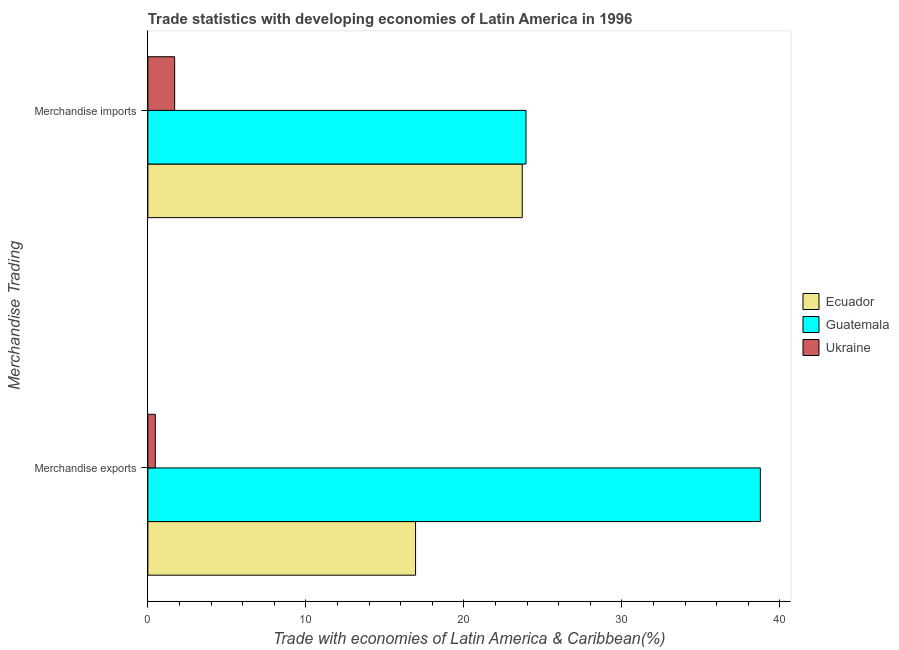How many different coloured bars are there?
Your response must be concise. 3. Are the number of bars per tick equal to the number of legend labels?
Ensure brevity in your answer.  Yes. Are the number of bars on each tick of the Y-axis equal?
Provide a succinct answer. Yes. How many bars are there on the 2nd tick from the bottom?
Your response must be concise. 3. What is the merchandise exports in Ukraine?
Provide a succinct answer. 0.47. Across all countries, what is the maximum merchandise exports?
Offer a very short reply. 38.77. Across all countries, what is the minimum merchandise imports?
Provide a succinct answer. 1.7. In which country was the merchandise imports maximum?
Your response must be concise. Guatemala. In which country was the merchandise imports minimum?
Make the answer very short. Ukraine. What is the total merchandise exports in the graph?
Offer a very short reply. 56.18. What is the difference between the merchandise imports in Guatemala and that in Ukraine?
Offer a terse response. 22.24. What is the difference between the merchandise imports in Ukraine and the merchandise exports in Ecuador?
Your answer should be very brief. -15.25. What is the average merchandise exports per country?
Your response must be concise. 18.73. What is the difference between the merchandise imports and merchandise exports in Ukraine?
Your answer should be compact. 1.23. What is the ratio of the merchandise exports in Ecuador to that in Ukraine?
Provide a succinct answer. 36.04. What does the 2nd bar from the top in Merchandise exports represents?
Keep it short and to the point. Guatemala. What does the 1st bar from the bottom in Merchandise exports represents?
Your answer should be compact. Ecuador. Are the values on the major ticks of X-axis written in scientific E-notation?
Make the answer very short. No. Does the graph contain any zero values?
Your response must be concise. No. What is the title of the graph?
Give a very brief answer. Trade statistics with developing economies of Latin America in 1996. What is the label or title of the X-axis?
Your answer should be very brief. Trade with economies of Latin America & Caribbean(%). What is the label or title of the Y-axis?
Offer a very short reply. Merchandise Trading. What is the Trade with economies of Latin America & Caribbean(%) in Ecuador in Merchandise exports?
Offer a very short reply. 16.94. What is the Trade with economies of Latin America & Caribbean(%) of Guatemala in Merchandise exports?
Your response must be concise. 38.77. What is the Trade with economies of Latin America & Caribbean(%) in Ukraine in Merchandise exports?
Provide a short and direct response. 0.47. What is the Trade with economies of Latin America & Caribbean(%) in Ecuador in Merchandise imports?
Offer a very short reply. 23.7. What is the Trade with economies of Latin America & Caribbean(%) in Guatemala in Merchandise imports?
Provide a succinct answer. 23.94. What is the Trade with economies of Latin America & Caribbean(%) of Ukraine in Merchandise imports?
Make the answer very short. 1.7. Across all Merchandise Trading, what is the maximum Trade with economies of Latin America & Caribbean(%) of Ecuador?
Ensure brevity in your answer.  23.7. Across all Merchandise Trading, what is the maximum Trade with economies of Latin America & Caribbean(%) in Guatemala?
Ensure brevity in your answer.  38.77. Across all Merchandise Trading, what is the maximum Trade with economies of Latin America & Caribbean(%) in Ukraine?
Make the answer very short. 1.7. Across all Merchandise Trading, what is the minimum Trade with economies of Latin America & Caribbean(%) of Ecuador?
Offer a very short reply. 16.94. Across all Merchandise Trading, what is the minimum Trade with economies of Latin America & Caribbean(%) in Guatemala?
Your response must be concise. 23.94. Across all Merchandise Trading, what is the minimum Trade with economies of Latin America & Caribbean(%) of Ukraine?
Provide a short and direct response. 0.47. What is the total Trade with economies of Latin America & Caribbean(%) of Ecuador in the graph?
Make the answer very short. 40.64. What is the total Trade with economies of Latin America & Caribbean(%) in Guatemala in the graph?
Your answer should be compact. 62.7. What is the total Trade with economies of Latin America & Caribbean(%) in Ukraine in the graph?
Keep it short and to the point. 2.17. What is the difference between the Trade with economies of Latin America & Caribbean(%) in Ecuador in Merchandise exports and that in Merchandise imports?
Provide a succinct answer. -6.75. What is the difference between the Trade with economies of Latin America & Caribbean(%) in Guatemala in Merchandise exports and that in Merchandise imports?
Offer a terse response. 14.83. What is the difference between the Trade with economies of Latin America & Caribbean(%) in Ukraine in Merchandise exports and that in Merchandise imports?
Give a very brief answer. -1.23. What is the difference between the Trade with economies of Latin America & Caribbean(%) in Ecuador in Merchandise exports and the Trade with economies of Latin America & Caribbean(%) in Guatemala in Merchandise imports?
Provide a short and direct response. -6.99. What is the difference between the Trade with economies of Latin America & Caribbean(%) of Ecuador in Merchandise exports and the Trade with economies of Latin America & Caribbean(%) of Ukraine in Merchandise imports?
Keep it short and to the point. 15.25. What is the difference between the Trade with economies of Latin America & Caribbean(%) in Guatemala in Merchandise exports and the Trade with economies of Latin America & Caribbean(%) in Ukraine in Merchandise imports?
Provide a short and direct response. 37.07. What is the average Trade with economies of Latin America & Caribbean(%) in Ecuador per Merchandise Trading?
Your response must be concise. 20.32. What is the average Trade with economies of Latin America & Caribbean(%) of Guatemala per Merchandise Trading?
Your response must be concise. 31.35. What is the average Trade with economies of Latin America & Caribbean(%) in Ukraine per Merchandise Trading?
Provide a succinct answer. 1.08. What is the difference between the Trade with economies of Latin America & Caribbean(%) of Ecuador and Trade with economies of Latin America & Caribbean(%) of Guatemala in Merchandise exports?
Make the answer very short. -21.82. What is the difference between the Trade with economies of Latin America & Caribbean(%) in Ecuador and Trade with economies of Latin America & Caribbean(%) in Ukraine in Merchandise exports?
Your answer should be very brief. 16.47. What is the difference between the Trade with economies of Latin America & Caribbean(%) in Guatemala and Trade with economies of Latin America & Caribbean(%) in Ukraine in Merchandise exports?
Offer a very short reply. 38.3. What is the difference between the Trade with economies of Latin America & Caribbean(%) of Ecuador and Trade with economies of Latin America & Caribbean(%) of Guatemala in Merchandise imports?
Offer a terse response. -0.24. What is the difference between the Trade with economies of Latin America & Caribbean(%) of Ecuador and Trade with economies of Latin America & Caribbean(%) of Ukraine in Merchandise imports?
Give a very brief answer. 22. What is the difference between the Trade with economies of Latin America & Caribbean(%) in Guatemala and Trade with economies of Latin America & Caribbean(%) in Ukraine in Merchandise imports?
Your response must be concise. 22.24. What is the ratio of the Trade with economies of Latin America & Caribbean(%) in Ecuador in Merchandise exports to that in Merchandise imports?
Keep it short and to the point. 0.71. What is the ratio of the Trade with economies of Latin America & Caribbean(%) in Guatemala in Merchandise exports to that in Merchandise imports?
Provide a succinct answer. 1.62. What is the ratio of the Trade with economies of Latin America & Caribbean(%) of Ukraine in Merchandise exports to that in Merchandise imports?
Provide a succinct answer. 0.28. What is the difference between the highest and the second highest Trade with economies of Latin America & Caribbean(%) in Ecuador?
Your response must be concise. 6.75. What is the difference between the highest and the second highest Trade with economies of Latin America & Caribbean(%) in Guatemala?
Make the answer very short. 14.83. What is the difference between the highest and the second highest Trade with economies of Latin America & Caribbean(%) of Ukraine?
Your response must be concise. 1.23. What is the difference between the highest and the lowest Trade with economies of Latin America & Caribbean(%) of Ecuador?
Ensure brevity in your answer.  6.75. What is the difference between the highest and the lowest Trade with economies of Latin America & Caribbean(%) in Guatemala?
Keep it short and to the point. 14.83. What is the difference between the highest and the lowest Trade with economies of Latin America & Caribbean(%) in Ukraine?
Offer a very short reply. 1.23. 